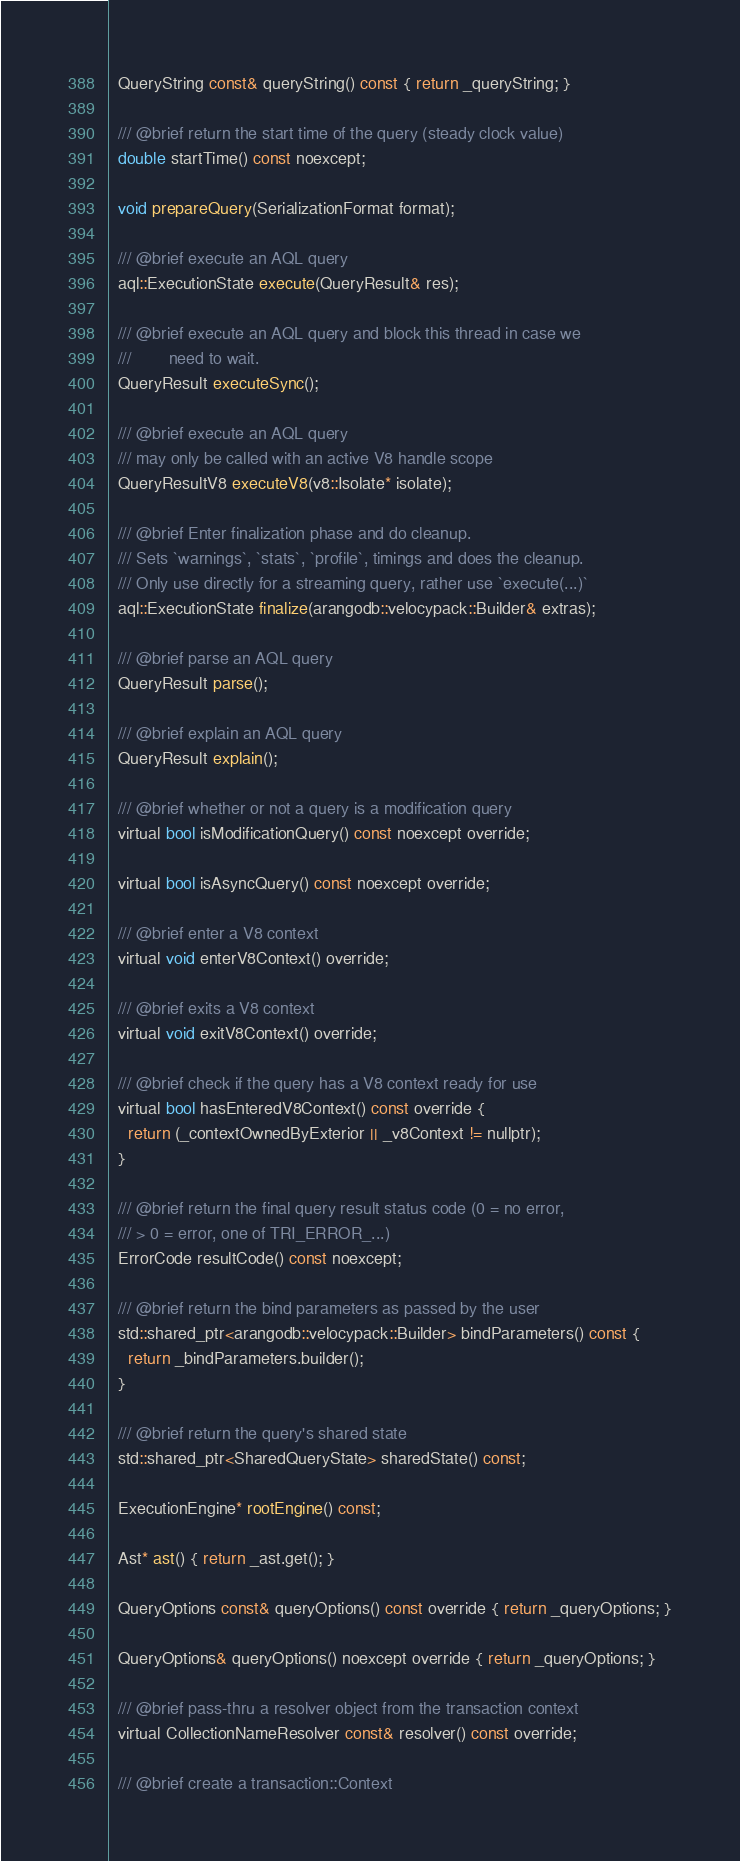Convert code to text. <code><loc_0><loc_0><loc_500><loc_500><_C_>  QueryString const& queryString() const { return _queryString; }

  /// @brief return the start time of the query (steady clock value)
  double startTime() const noexcept;

  void prepareQuery(SerializationFormat format);

  /// @brief execute an AQL query
  aql::ExecutionState execute(QueryResult& res);

  /// @brief execute an AQL query and block this thread in case we
  ///        need to wait.
  QueryResult executeSync();

  /// @brief execute an AQL query
  /// may only be called with an active V8 handle scope
  QueryResultV8 executeV8(v8::Isolate* isolate);

  /// @brief Enter finalization phase and do cleanup.
  /// Sets `warnings`, `stats`, `profile`, timings and does the cleanup.
  /// Only use directly for a streaming query, rather use `execute(...)`
  aql::ExecutionState finalize(arangodb::velocypack::Builder& extras);

  /// @brief parse an AQL query
  QueryResult parse();

  /// @brief explain an AQL query
  QueryResult explain();

  /// @brief whether or not a query is a modification query
  virtual bool isModificationQuery() const noexcept override;

  virtual bool isAsyncQuery() const noexcept override;

  /// @brief enter a V8 context
  virtual void enterV8Context() override;

  /// @brief exits a V8 context
  virtual void exitV8Context() override;

  /// @brief check if the query has a V8 context ready for use
  virtual bool hasEnteredV8Context() const override {
    return (_contextOwnedByExterior || _v8Context != nullptr);
  }

  /// @brief return the final query result status code (0 = no error,
  /// > 0 = error, one of TRI_ERROR_...)
  ErrorCode resultCode() const noexcept;

  /// @brief return the bind parameters as passed by the user
  std::shared_ptr<arangodb::velocypack::Builder> bindParameters() const {
    return _bindParameters.builder();
  }

  /// @brief return the query's shared state
  std::shared_ptr<SharedQueryState> sharedState() const;

  ExecutionEngine* rootEngine() const;

  Ast* ast() { return _ast.get(); }

  QueryOptions const& queryOptions() const override { return _queryOptions; }

  QueryOptions& queryOptions() noexcept override { return _queryOptions; }

  /// @brief pass-thru a resolver object from the transaction context
  virtual CollectionNameResolver const& resolver() const override;

  /// @brief create a transaction::Context</code> 